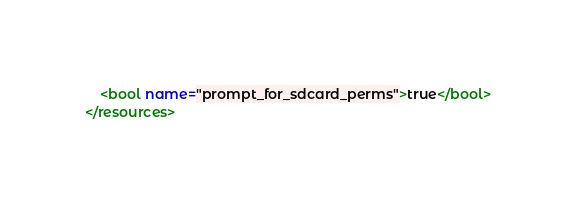<code> <loc_0><loc_0><loc_500><loc_500><_XML_>    <bool name="prompt_for_sdcard_perms">true</bool>
</resources>

</code> 